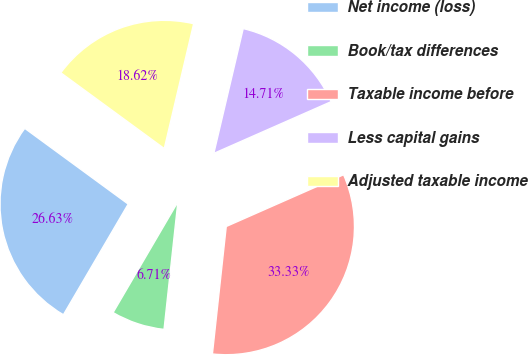<chart> <loc_0><loc_0><loc_500><loc_500><pie_chart><fcel>Net income (loss)<fcel>Book/tax differences<fcel>Taxable income before<fcel>Less capital gains<fcel>Adjusted taxable income<nl><fcel>26.63%<fcel>6.71%<fcel>33.33%<fcel>14.71%<fcel>18.62%<nl></chart> 